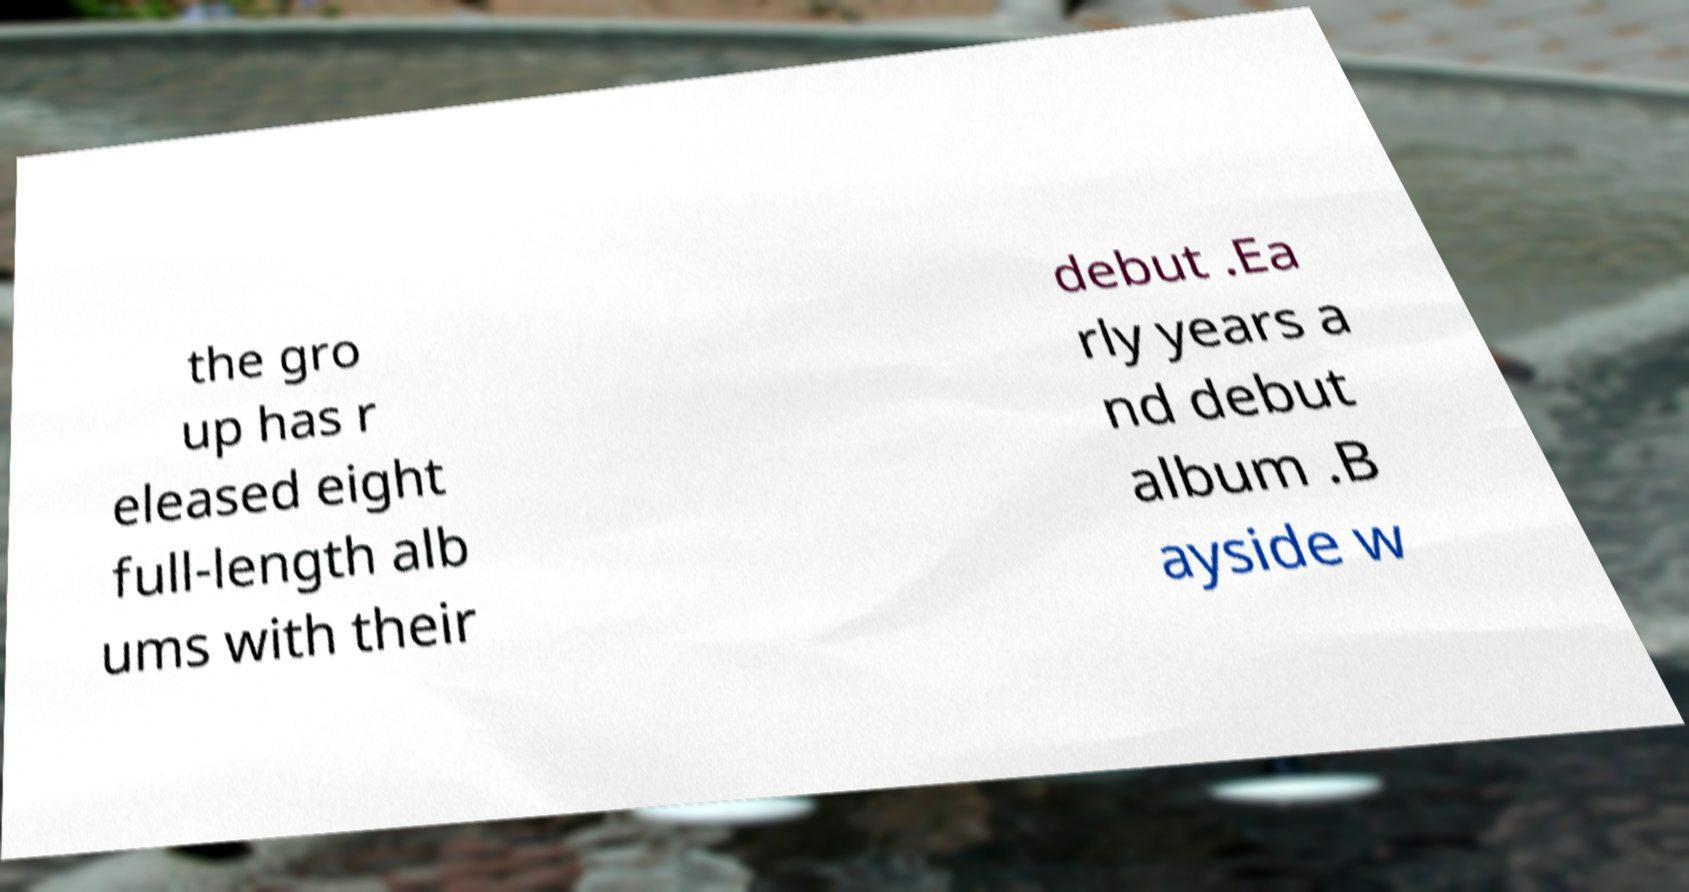Could you assist in decoding the text presented in this image and type it out clearly? the gro up has r eleased eight full-length alb ums with their debut .Ea rly years a nd debut album .B ayside w 